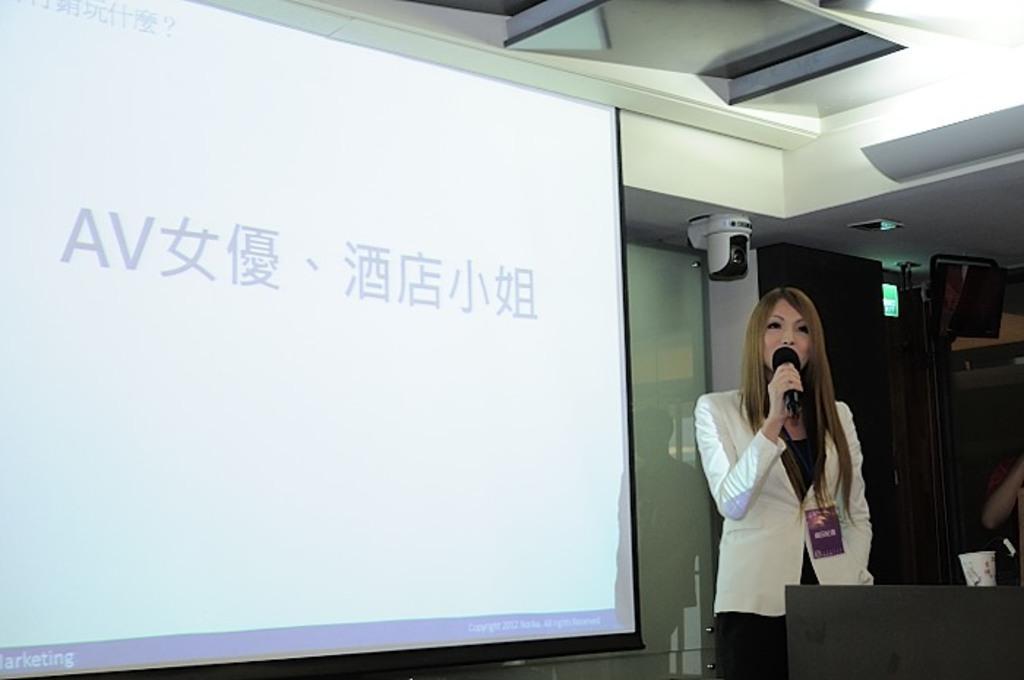In one or two sentences, can you explain what this image depicts? In this image we can see a lady standing and holding a microphone, behind her there is a projector screen and some text is projected on it, on the right side of the image there is a camera, lights and a few other objects, in front of her looks like there is a table and there is a glass on it. 